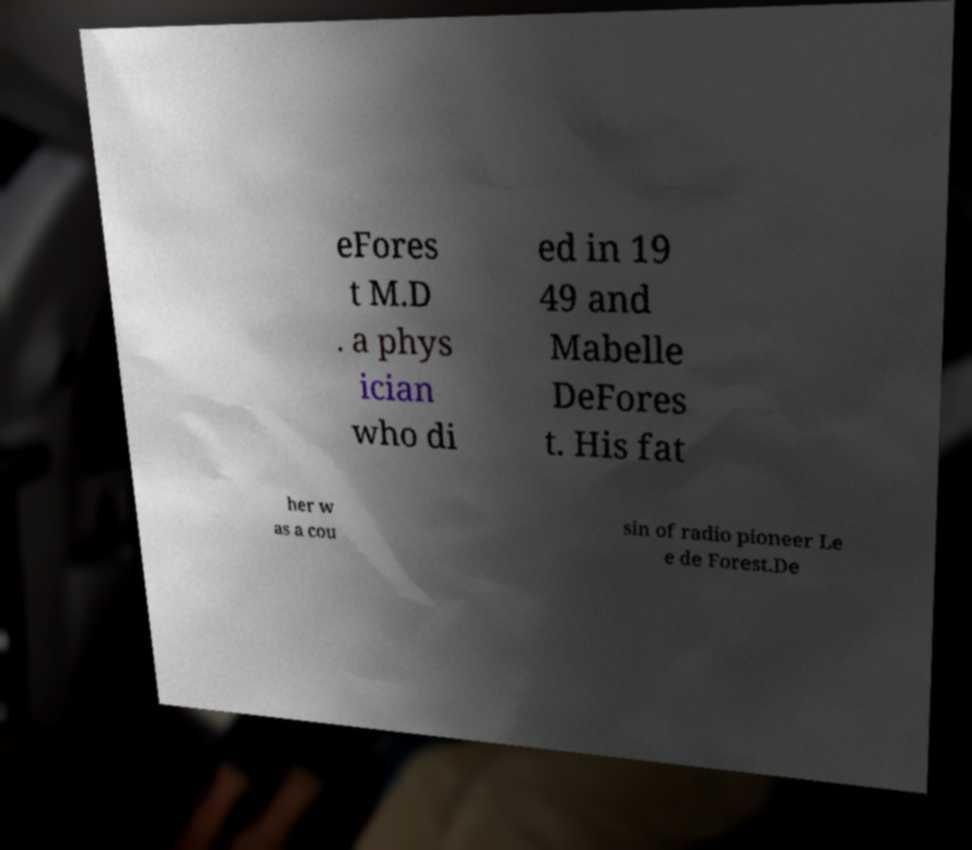Could you assist in decoding the text presented in this image and type it out clearly? eFores t M.D . a phys ician who di ed in 19 49 and Mabelle DeFores t. His fat her w as a cou sin of radio pioneer Le e de Forest.De 